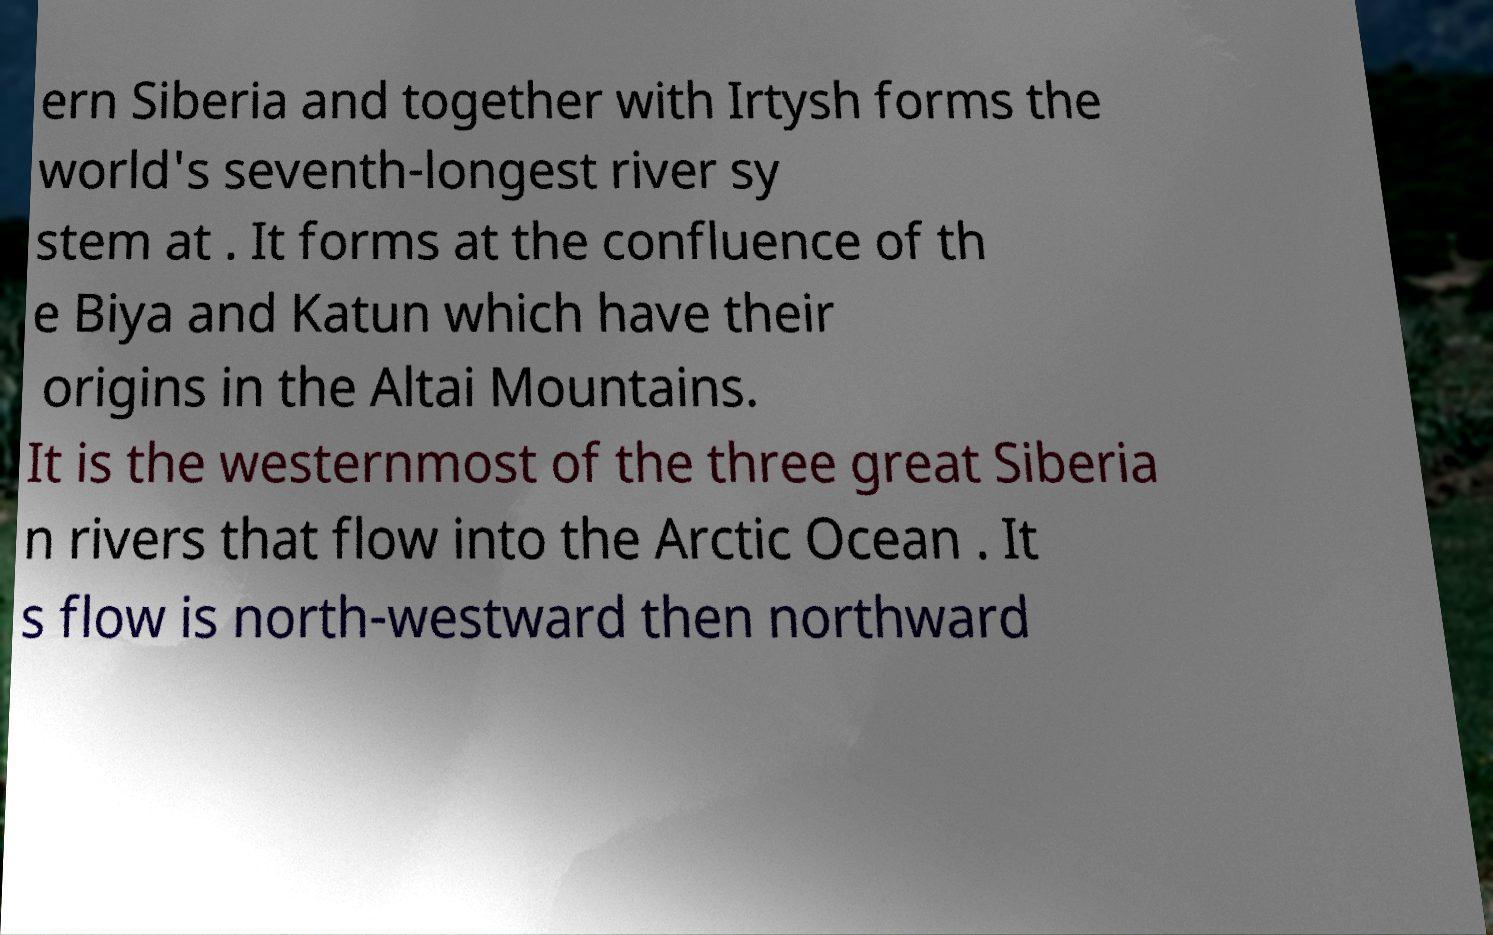I need the written content from this picture converted into text. Can you do that? ern Siberia and together with Irtysh forms the world's seventh-longest river sy stem at . It forms at the confluence of th e Biya and Katun which have their origins in the Altai Mountains. It is the westernmost of the three great Siberia n rivers that flow into the Arctic Ocean . It s flow is north-westward then northward 